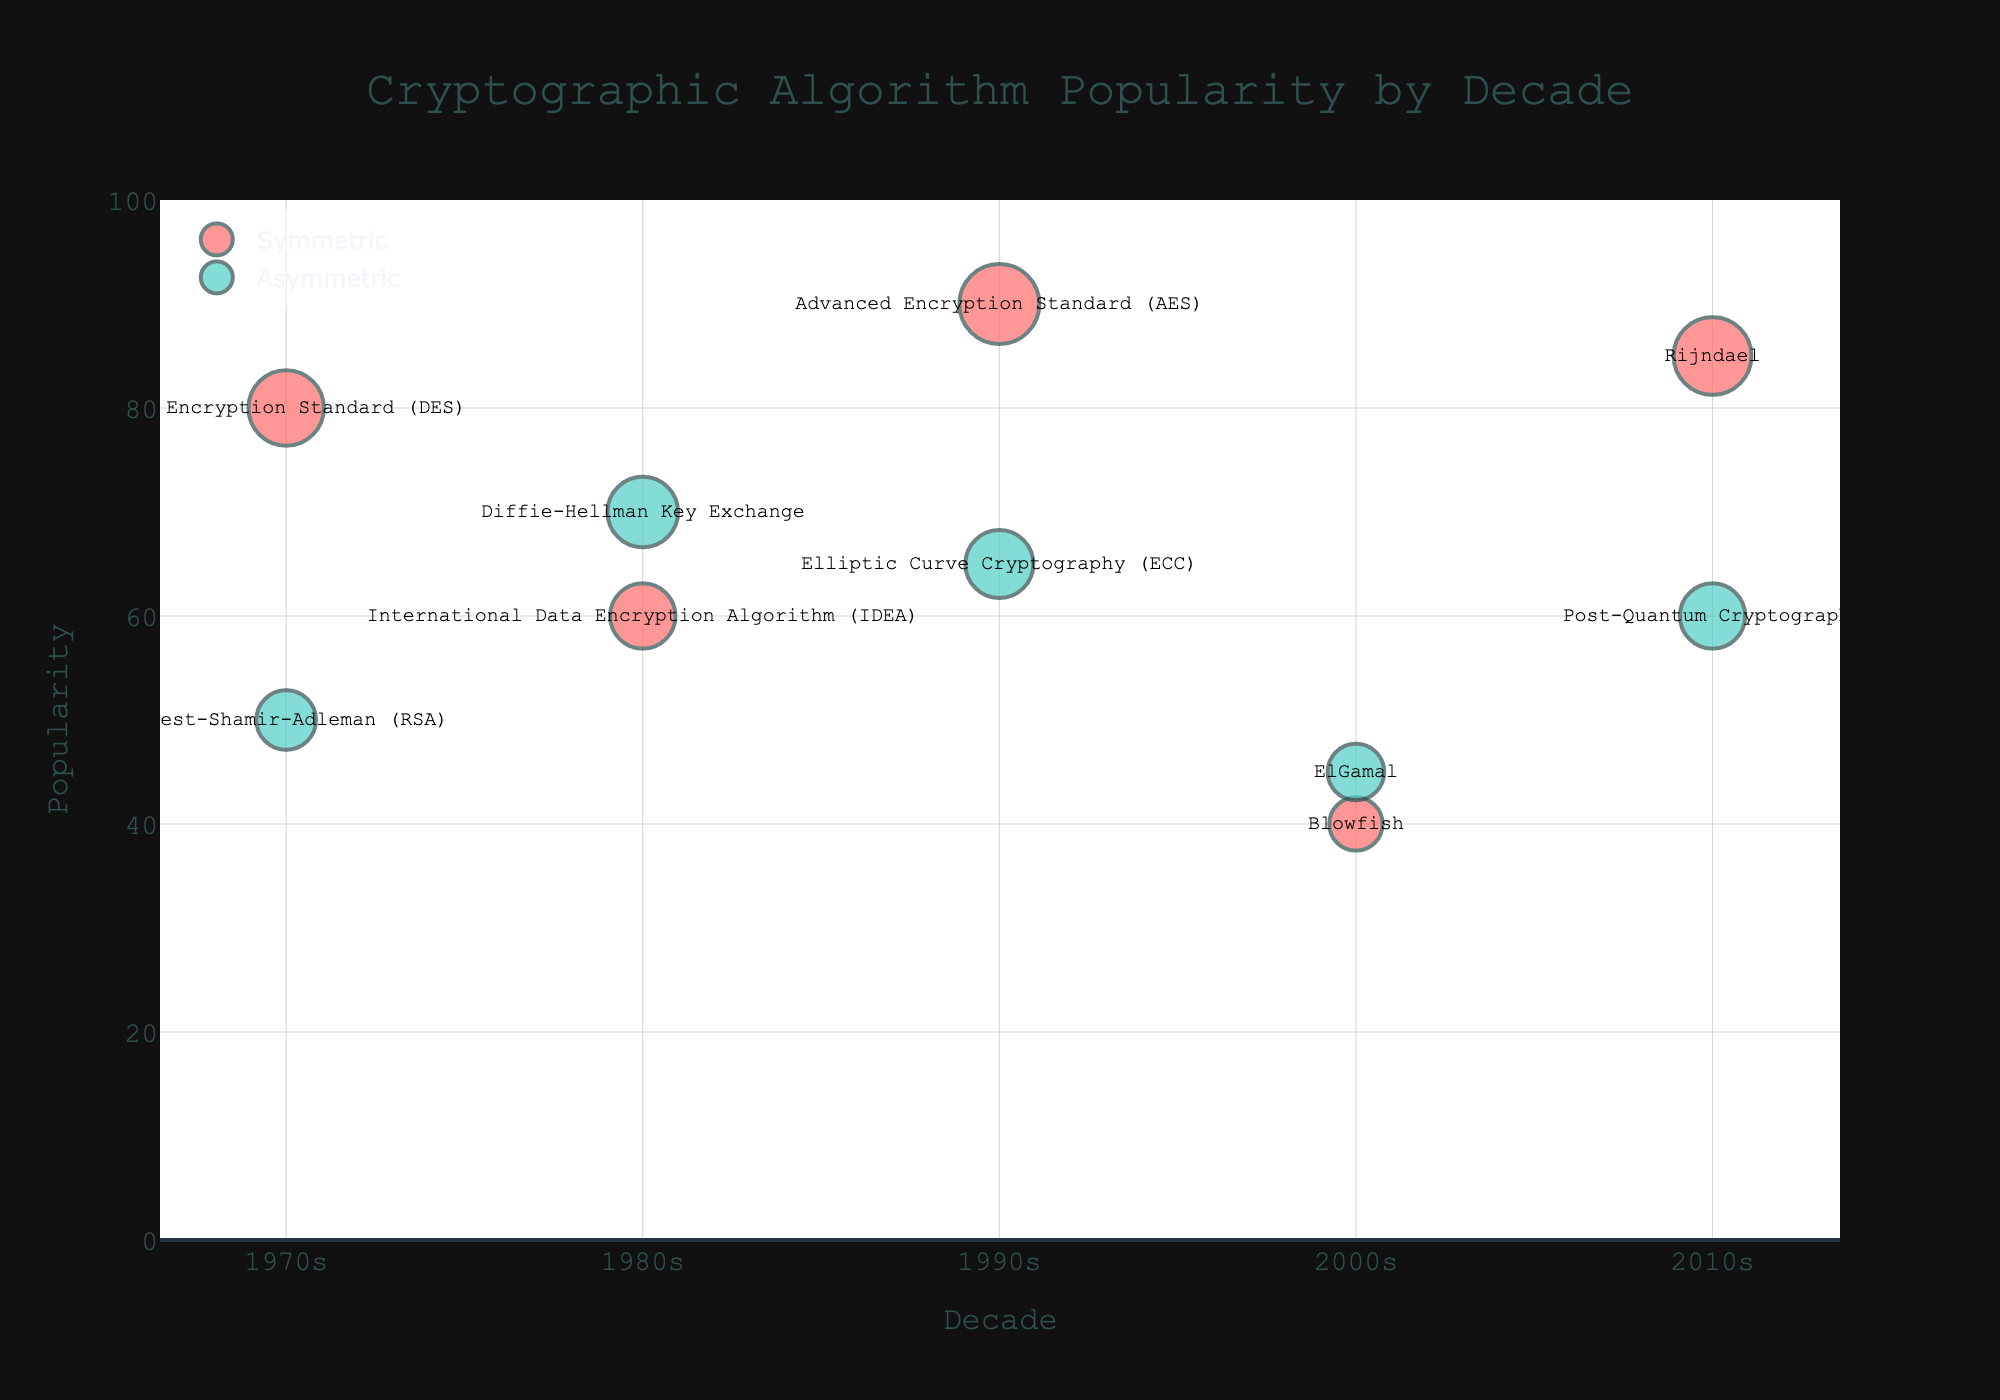How does the popularity of the Data Encryption Standard (DES) compare to Rivest-Shamir-Adleman (RSA) in the 1970s? DES has a popularity of 80 while RSA has a popularity of 50 in the 1970s, so DES is more popular.
Answer: DES is more popular Which decade saw the highest popularity for symmetric algorithms? The 1990s saw the Advanced Encryption Standard (AES) achieve a popularity of 90, which is higher than any other symmetric algorithm in any other decade.
Answer: 1990s What is the difference in popularity between Elliptic Curve Cryptography (ECC) and Post-Quantum Cryptography in the 2010s? ECC has a popularity of 65, and Post-Quantum Cryptography has a popularity of 60. The difference is 65 - 60 = 5.
Answer: 5 How many different algorithms are presented in the 2000s? Blowfish and ElGamal are the only two algorithms shown for the 2000s.
Answer: 2 What trend can be observed between symmetric and asymmetric algorithms over time? Symmetric algorithms tend to have higher popularity values compared to asymmetric algorithms in each given decade.
Answer: Symmetric algorithms are generally more popular Which algorithm in the 1980s has higher popularity, International Data Encryption Algorithm (IDEA) or Diffie-Hellman Key Exchange? Diffie-Hellman Key Exchange has a popularity of 70, while IDEA has a popularity of 60. Thus, Diffie-Hellman Key Exchange is more popular.
Answer: Diffie-Hellman Key Exchange What is the average popularity of symmetric algorithms in the 2010s? Rijndael is the only symmetric algorithm in the 2010s with a popularity of 85, so the average is 85.
Answer: 85 Compare the change in popularity of symmetric algorithms from the 1990s to the 2010s. In the 1990s, AES had a popularity of 90. In the 2010s, Rijndael had a popularity of 85. The change is 85 - 90 = -5.
Answer: -5 What color are the bubbles representing asymmetric algorithms? The bubbles for asymmetric algorithms are a teal or aqua color.
Answer: Teal/Aqua Between Blowfish and DES, which has a lower popularity value and by how much? Blowfish has a popularity of 40, and DES has a popularity of 80. The difference is 80 - 40 = 40.
Answer: Blowfish by 40 